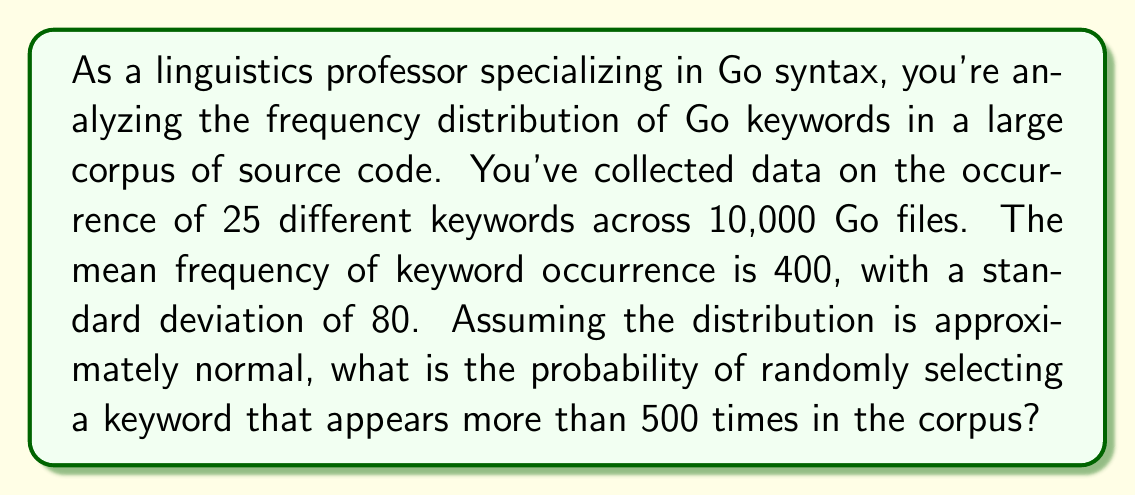Help me with this question. To solve this problem, we need to use the properties of the normal distribution and the concept of z-scores. Let's break it down step-by-step:

1. We're given:
   - Mean (μ) = 400
   - Standard deviation (σ) = 80
   - We want to find P(X > 500), where X is the frequency of a randomly selected keyword

2. First, we need to calculate the z-score for X = 500:

   $$z = \frac{X - \mu}{\sigma} = \frac{500 - 400}{80} = 1.25$$

3. Now, we need to find the probability of Z > 1.25 in a standard normal distribution.

4. This probability is equal to 1 minus the cumulative probability of Z ≤ 1.25:

   $$P(Z > 1.25) = 1 - P(Z \leq 1.25)$$

5. Using a standard normal distribution table or a statistical calculator, we can find:

   $$P(Z \leq 1.25) \approx 0.8944$$

6. Therefore:

   $$P(Z > 1.25) = 1 - 0.8944 = 0.1056$$

This means the probability of randomly selecting a keyword that appears more than 500 times in the corpus is approximately 0.1056 or 10.56%.
Answer: The probability of randomly selecting a Go keyword that appears more than 500 times in the corpus is approximately 0.1056 or 10.56%. 